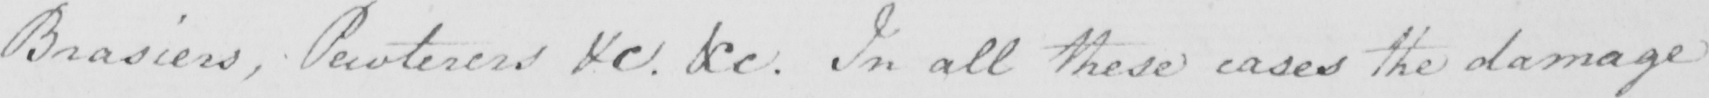Please transcribe the handwritten text in this image. Brasiers , Pewterers &c . &c . In all these cases the damage 